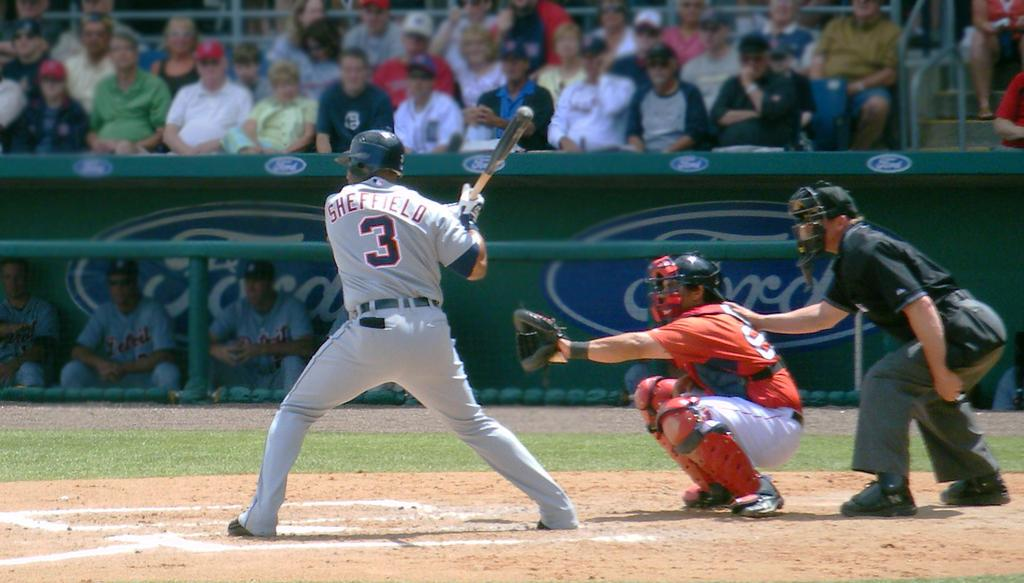<image>
Write a terse but informative summary of the picture. a player with the name Sheffield on their jersey 